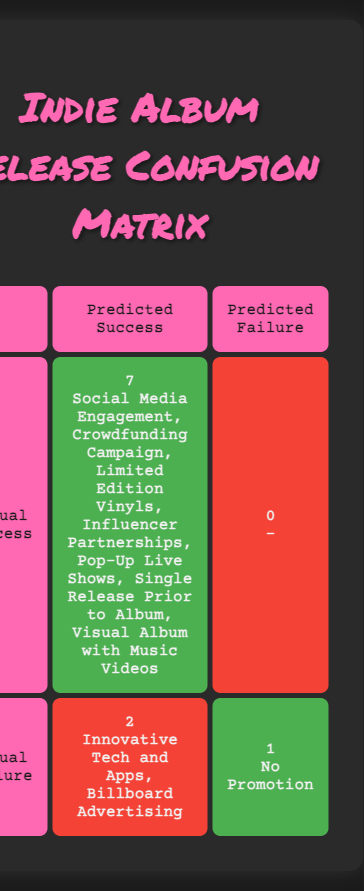What is the total number of marketing strategies listed in the table? There are two rows in the table representing two types of actual performance (success and failure), each containing specific marketing strategies. By counting the strategies listed under each outcome, we find seven successful strategies and two failed strategies. Therefore, the total is 7 + 2 = 9.
Answer: 9 How many marketing strategies predicted a successful album release but actually failed? Looking at the table, we check the "Predicted Success" column under the "Actual Failure" row. There is one marketing strategy (No Promotion) that predicted success but resulted in failure.
Answer: 1 Which marketing strategy had the highest count of successes? Referring to the "Actual Success" row, there are multiple listed strategies all resulting in success. Because they are all counted as successful (7), they don't have individual counts displayed. Hence, there’s no highest count as all are equal at one for success.
Answer: N/A Is there any marketing strategy that both predicted failure and resulted in success? Checking the "Predicted Failure" column under the "Actual Success" row reveals that none of the strategies listed here (0) were predicted to fail. This means there are no strategies that fit this criterion.
Answer: No What is the ratio of successful marketing strategies to failed ones? The table states there are 7 successful and 2 failed marketing strategies. To find the ratio, we divide the number of successful strategies by the number of failed strategies: 7 successful / 2 failed = 3.5. The ratio can be represented as 3.5:1.
Answer: 3.5:1 How many total album releases were analyzed according to the table? By counting all the individual successful and failed strategies listed in both rows, we find a total of 9 strategies were analyzed: 7 successful + 2 failed = 9 total album releases.
Answer: 9 Did any artists utilize a crowdfunding campaign that resulted in success? Referring to the table, Tash Sultana used a crowdfunding campaign, which is mentioned as a successful marketing strategy under "Actual Success." Therefore, the answer is yes.
Answer: Yes What are the unsuccessful marketing strategies listed in the table? By looking at the "Actual Failure" row, the unsuccessful strategies are Innovative Tech and Apps and Billboard Advertising. Thus, these two represent the failed strategies in the performance of marketing.
Answer: Innovative Tech and Apps, Billboard Advertising 